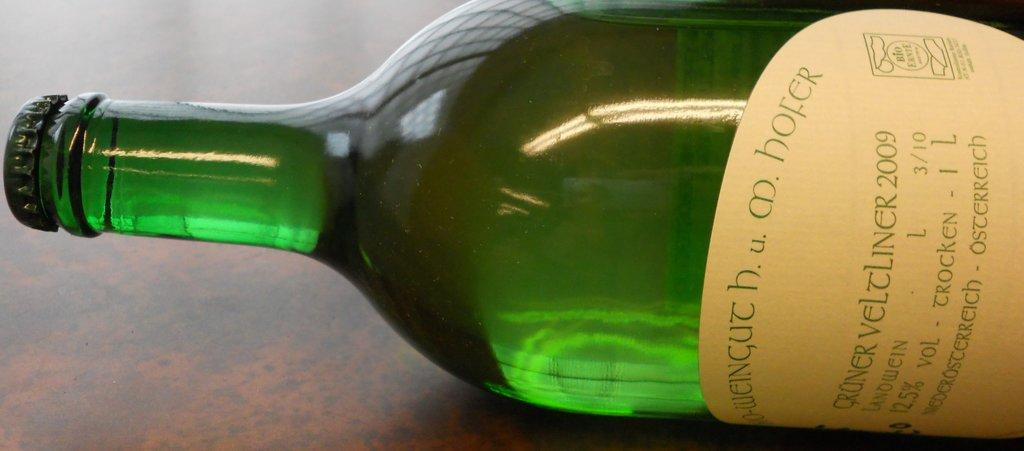Provide a one-sentence caption for the provided image. A beige labeled green bottle of German wine. 